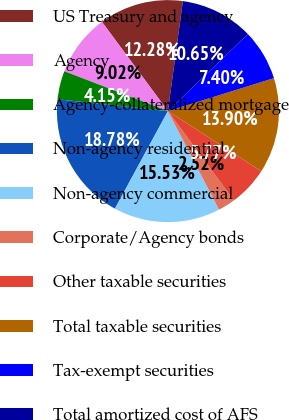Convert chart to OTSL. <chart><loc_0><loc_0><loc_500><loc_500><pie_chart><fcel>US Treasury and agency<fcel>Agency<fcel>Agency-collateralized mortgage<fcel>Non-agency residential<fcel>Non-agency commercial<fcel>Corporate/Agency bonds<fcel>Other taxable securities<fcel>Total taxable securities<fcel>Tax-exempt securities<fcel>Total amortized cost of AFS<nl><fcel>12.28%<fcel>9.02%<fcel>4.15%<fcel>18.78%<fcel>15.53%<fcel>2.52%<fcel>5.77%<fcel>13.9%<fcel>7.4%<fcel>10.65%<nl></chart> 